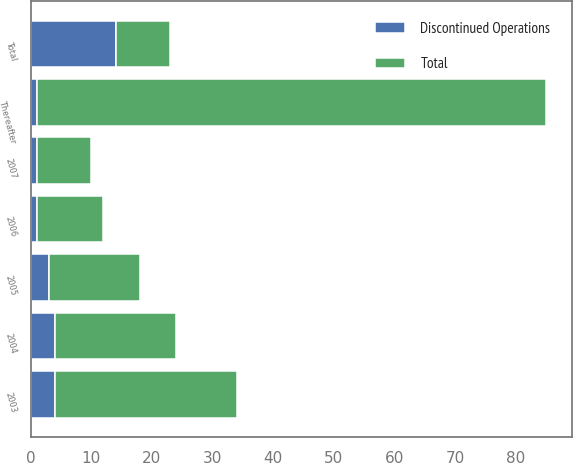<chart> <loc_0><loc_0><loc_500><loc_500><stacked_bar_chart><ecel><fcel>2003<fcel>2004<fcel>2005<fcel>2006<fcel>2007<fcel>Thereafter<fcel>Total<nl><fcel>Total<fcel>30<fcel>20<fcel>15<fcel>11<fcel>9<fcel>84<fcel>9<nl><fcel>Discontinued Operations<fcel>4<fcel>4<fcel>3<fcel>1<fcel>1<fcel>1<fcel>14<nl></chart> 